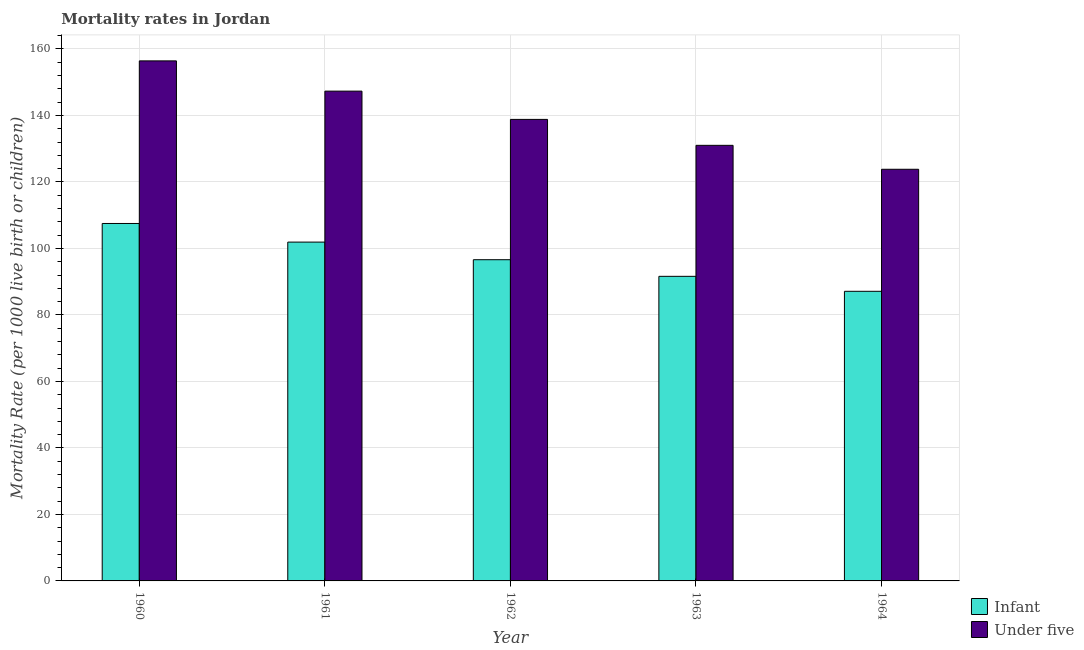How many groups of bars are there?
Provide a short and direct response. 5. How many bars are there on the 4th tick from the right?
Give a very brief answer. 2. What is the label of the 2nd group of bars from the left?
Give a very brief answer. 1961. What is the under-5 mortality rate in 1962?
Your response must be concise. 138.8. Across all years, what is the maximum infant mortality rate?
Your response must be concise. 107.5. Across all years, what is the minimum under-5 mortality rate?
Provide a short and direct response. 123.8. In which year was the infant mortality rate maximum?
Ensure brevity in your answer.  1960. In which year was the infant mortality rate minimum?
Give a very brief answer. 1964. What is the total infant mortality rate in the graph?
Provide a succinct answer. 484.7. What is the difference between the under-5 mortality rate in 1960 and that in 1961?
Provide a short and direct response. 9.1. What is the average under-5 mortality rate per year?
Make the answer very short. 139.46. In the year 1960, what is the difference between the under-5 mortality rate and infant mortality rate?
Offer a terse response. 0. What is the ratio of the under-5 mortality rate in 1960 to that in 1962?
Make the answer very short. 1.13. What is the difference between the highest and the second highest under-5 mortality rate?
Offer a terse response. 9.1. What is the difference between the highest and the lowest under-5 mortality rate?
Give a very brief answer. 32.6. In how many years, is the infant mortality rate greater than the average infant mortality rate taken over all years?
Make the answer very short. 2. What does the 1st bar from the left in 1963 represents?
Your answer should be very brief. Infant. What does the 1st bar from the right in 1964 represents?
Provide a short and direct response. Under five. How many bars are there?
Keep it short and to the point. 10. What is the difference between two consecutive major ticks on the Y-axis?
Provide a short and direct response. 20. Does the graph contain grids?
Your answer should be compact. Yes. Where does the legend appear in the graph?
Your answer should be very brief. Bottom right. How are the legend labels stacked?
Your answer should be compact. Vertical. What is the title of the graph?
Give a very brief answer. Mortality rates in Jordan. What is the label or title of the Y-axis?
Your response must be concise. Mortality Rate (per 1000 live birth or children). What is the Mortality Rate (per 1000 live birth or children) in Infant in 1960?
Ensure brevity in your answer.  107.5. What is the Mortality Rate (per 1000 live birth or children) of Under five in 1960?
Your answer should be very brief. 156.4. What is the Mortality Rate (per 1000 live birth or children) in Infant in 1961?
Ensure brevity in your answer.  101.9. What is the Mortality Rate (per 1000 live birth or children) of Under five in 1961?
Make the answer very short. 147.3. What is the Mortality Rate (per 1000 live birth or children) in Infant in 1962?
Provide a succinct answer. 96.6. What is the Mortality Rate (per 1000 live birth or children) in Under five in 1962?
Ensure brevity in your answer.  138.8. What is the Mortality Rate (per 1000 live birth or children) in Infant in 1963?
Ensure brevity in your answer.  91.6. What is the Mortality Rate (per 1000 live birth or children) of Under five in 1963?
Your response must be concise. 131. What is the Mortality Rate (per 1000 live birth or children) in Infant in 1964?
Make the answer very short. 87.1. What is the Mortality Rate (per 1000 live birth or children) of Under five in 1964?
Your answer should be compact. 123.8. Across all years, what is the maximum Mortality Rate (per 1000 live birth or children) in Infant?
Your answer should be compact. 107.5. Across all years, what is the maximum Mortality Rate (per 1000 live birth or children) in Under five?
Your response must be concise. 156.4. Across all years, what is the minimum Mortality Rate (per 1000 live birth or children) in Infant?
Provide a short and direct response. 87.1. Across all years, what is the minimum Mortality Rate (per 1000 live birth or children) in Under five?
Your answer should be very brief. 123.8. What is the total Mortality Rate (per 1000 live birth or children) of Infant in the graph?
Offer a terse response. 484.7. What is the total Mortality Rate (per 1000 live birth or children) of Under five in the graph?
Offer a very short reply. 697.3. What is the difference between the Mortality Rate (per 1000 live birth or children) in Under five in 1960 and that in 1961?
Your answer should be compact. 9.1. What is the difference between the Mortality Rate (per 1000 live birth or children) in Infant in 1960 and that in 1962?
Your answer should be compact. 10.9. What is the difference between the Mortality Rate (per 1000 live birth or children) of Infant in 1960 and that in 1963?
Offer a very short reply. 15.9. What is the difference between the Mortality Rate (per 1000 live birth or children) in Under five in 1960 and that in 1963?
Keep it short and to the point. 25.4. What is the difference between the Mortality Rate (per 1000 live birth or children) in Infant in 1960 and that in 1964?
Ensure brevity in your answer.  20.4. What is the difference between the Mortality Rate (per 1000 live birth or children) of Under five in 1960 and that in 1964?
Your answer should be very brief. 32.6. What is the difference between the Mortality Rate (per 1000 live birth or children) in Under five in 1961 and that in 1962?
Your answer should be compact. 8.5. What is the difference between the Mortality Rate (per 1000 live birth or children) in Infant in 1961 and that in 1963?
Your response must be concise. 10.3. What is the difference between the Mortality Rate (per 1000 live birth or children) of Infant in 1960 and the Mortality Rate (per 1000 live birth or children) of Under five in 1961?
Make the answer very short. -39.8. What is the difference between the Mortality Rate (per 1000 live birth or children) of Infant in 1960 and the Mortality Rate (per 1000 live birth or children) of Under five in 1962?
Provide a short and direct response. -31.3. What is the difference between the Mortality Rate (per 1000 live birth or children) in Infant in 1960 and the Mortality Rate (per 1000 live birth or children) in Under five in 1963?
Your response must be concise. -23.5. What is the difference between the Mortality Rate (per 1000 live birth or children) in Infant in 1960 and the Mortality Rate (per 1000 live birth or children) in Under five in 1964?
Make the answer very short. -16.3. What is the difference between the Mortality Rate (per 1000 live birth or children) in Infant in 1961 and the Mortality Rate (per 1000 live birth or children) in Under five in 1962?
Offer a terse response. -36.9. What is the difference between the Mortality Rate (per 1000 live birth or children) in Infant in 1961 and the Mortality Rate (per 1000 live birth or children) in Under five in 1963?
Provide a short and direct response. -29.1. What is the difference between the Mortality Rate (per 1000 live birth or children) of Infant in 1961 and the Mortality Rate (per 1000 live birth or children) of Under five in 1964?
Offer a terse response. -21.9. What is the difference between the Mortality Rate (per 1000 live birth or children) of Infant in 1962 and the Mortality Rate (per 1000 live birth or children) of Under five in 1963?
Your answer should be very brief. -34.4. What is the difference between the Mortality Rate (per 1000 live birth or children) of Infant in 1962 and the Mortality Rate (per 1000 live birth or children) of Under five in 1964?
Your answer should be compact. -27.2. What is the difference between the Mortality Rate (per 1000 live birth or children) in Infant in 1963 and the Mortality Rate (per 1000 live birth or children) in Under five in 1964?
Offer a very short reply. -32.2. What is the average Mortality Rate (per 1000 live birth or children) of Infant per year?
Offer a very short reply. 96.94. What is the average Mortality Rate (per 1000 live birth or children) in Under five per year?
Offer a very short reply. 139.46. In the year 1960, what is the difference between the Mortality Rate (per 1000 live birth or children) in Infant and Mortality Rate (per 1000 live birth or children) in Under five?
Your response must be concise. -48.9. In the year 1961, what is the difference between the Mortality Rate (per 1000 live birth or children) of Infant and Mortality Rate (per 1000 live birth or children) of Under five?
Keep it short and to the point. -45.4. In the year 1962, what is the difference between the Mortality Rate (per 1000 live birth or children) of Infant and Mortality Rate (per 1000 live birth or children) of Under five?
Your answer should be compact. -42.2. In the year 1963, what is the difference between the Mortality Rate (per 1000 live birth or children) in Infant and Mortality Rate (per 1000 live birth or children) in Under five?
Offer a very short reply. -39.4. In the year 1964, what is the difference between the Mortality Rate (per 1000 live birth or children) in Infant and Mortality Rate (per 1000 live birth or children) in Under five?
Give a very brief answer. -36.7. What is the ratio of the Mortality Rate (per 1000 live birth or children) of Infant in 1960 to that in 1961?
Provide a succinct answer. 1.05. What is the ratio of the Mortality Rate (per 1000 live birth or children) of Under five in 1960 to that in 1961?
Make the answer very short. 1.06. What is the ratio of the Mortality Rate (per 1000 live birth or children) in Infant in 1960 to that in 1962?
Provide a short and direct response. 1.11. What is the ratio of the Mortality Rate (per 1000 live birth or children) of Under five in 1960 to that in 1962?
Offer a terse response. 1.13. What is the ratio of the Mortality Rate (per 1000 live birth or children) in Infant in 1960 to that in 1963?
Offer a terse response. 1.17. What is the ratio of the Mortality Rate (per 1000 live birth or children) in Under five in 1960 to that in 1963?
Provide a succinct answer. 1.19. What is the ratio of the Mortality Rate (per 1000 live birth or children) in Infant in 1960 to that in 1964?
Provide a succinct answer. 1.23. What is the ratio of the Mortality Rate (per 1000 live birth or children) in Under five in 1960 to that in 1964?
Your answer should be very brief. 1.26. What is the ratio of the Mortality Rate (per 1000 live birth or children) of Infant in 1961 to that in 1962?
Your answer should be compact. 1.05. What is the ratio of the Mortality Rate (per 1000 live birth or children) of Under five in 1961 to that in 1962?
Offer a terse response. 1.06. What is the ratio of the Mortality Rate (per 1000 live birth or children) of Infant in 1961 to that in 1963?
Your answer should be very brief. 1.11. What is the ratio of the Mortality Rate (per 1000 live birth or children) in Under five in 1961 to that in 1963?
Give a very brief answer. 1.12. What is the ratio of the Mortality Rate (per 1000 live birth or children) in Infant in 1961 to that in 1964?
Provide a succinct answer. 1.17. What is the ratio of the Mortality Rate (per 1000 live birth or children) in Under five in 1961 to that in 1964?
Your response must be concise. 1.19. What is the ratio of the Mortality Rate (per 1000 live birth or children) in Infant in 1962 to that in 1963?
Ensure brevity in your answer.  1.05. What is the ratio of the Mortality Rate (per 1000 live birth or children) of Under five in 1962 to that in 1963?
Ensure brevity in your answer.  1.06. What is the ratio of the Mortality Rate (per 1000 live birth or children) of Infant in 1962 to that in 1964?
Give a very brief answer. 1.11. What is the ratio of the Mortality Rate (per 1000 live birth or children) of Under five in 1962 to that in 1964?
Ensure brevity in your answer.  1.12. What is the ratio of the Mortality Rate (per 1000 live birth or children) of Infant in 1963 to that in 1964?
Offer a very short reply. 1.05. What is the ratio of the Mortality Rate (per 1000 live birth or children) of Under five in 1963 to that in 1964?
Offer a terse response. 1.06. What is the difference between the highest and the second highest Mortality Rate (per 1000 live birth or children) in Infant?
Ensure brevity in your answer.  5.6. What is the difference between the highest and the second highest Mortality Rate (per 1000 live birth or children) in Under five?
Make the answer very short. 9.1. What is the difference between the highest and the lowest Mortality Rate (per 1000 live birth or children) in Infant?
Your response must be concise. 20.4. What is the difference between the highest and the lowest Mortality Rate (per 1000 live birth or children) in Under five?
Your answer should be very brief. 32.6. 